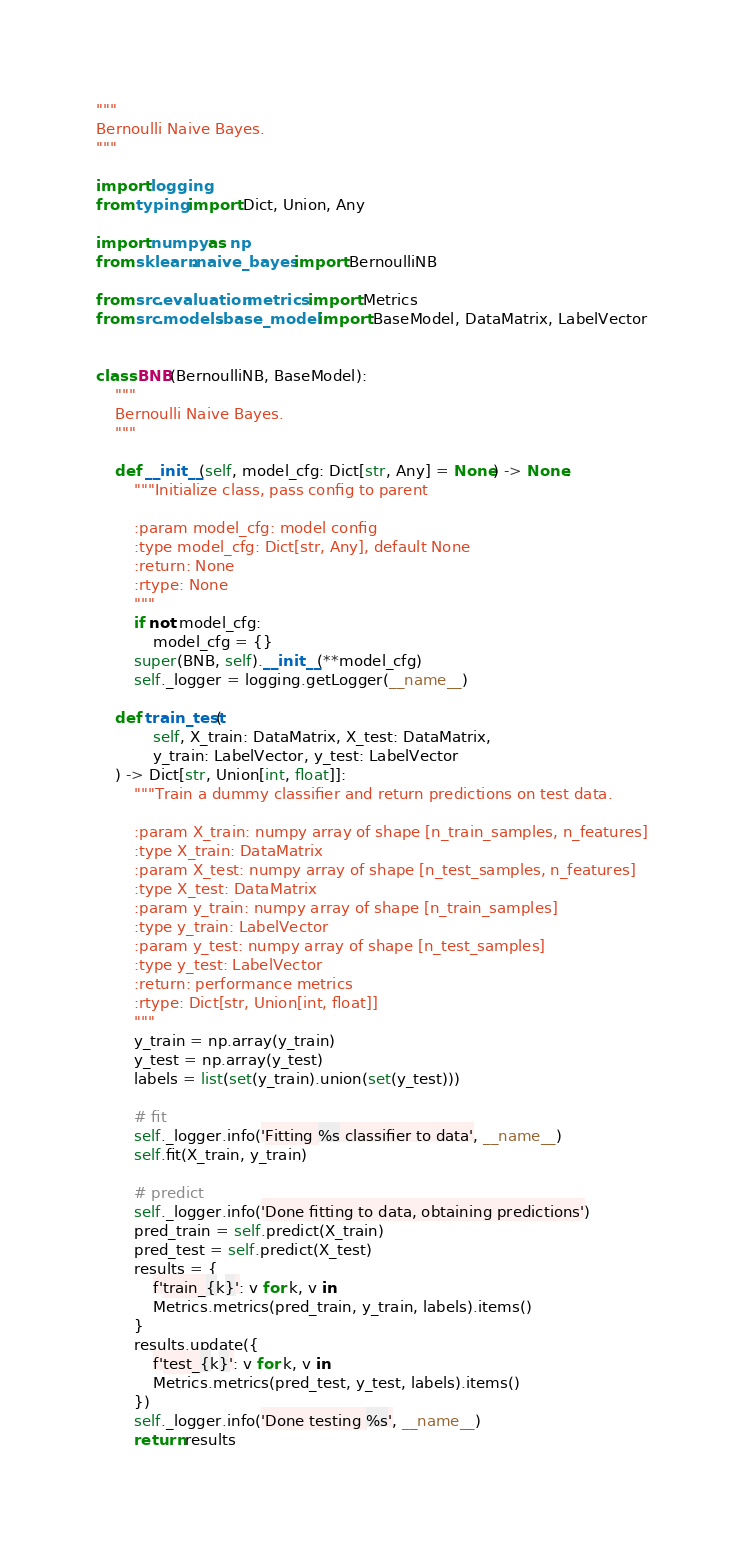Convert code to text. <code><loc_0><loc_0><loc_500><loc_500><_Python_>"""
Bernoulli Naive Bayes.
"""

import logging
from typing import Dict, Union, Any

import numpy as np
from sklearn.naive_bayes import BernoulliNB

from src.evaluation.metrics import Metrics
from src.models.base_model import BaseModel, DataMatrix, LabelVector


class BNB(BernoulliNB, BaseModel):
    """
    Bernoulli Naive Bayes.
    """

    def __init__(self, model_cfg: Dict[str, Any] = None) -> None:
        """Initialize class, pass config to parent

        :param model_cfg: model config
        :type model_cfg: Dict[str, Any], default None
        :return: None
        :rtype: None
        """
        if not model_cfg:
            model_cfg = {}
        super(BNB, self).__init__(**model_cfg)
        self._logger = logging.getLogger(__name__)

    def train_test(
            self, X_train: DataMatrix, X_test: DataMatrix,
            y_train: LabelVector, y_test: LabelVector
    ) -> Dict[str, Union[int, float]]:
        """Train a dummy classifier and return predictions on test data.

        :param X_train: numpy array of shape [n_train_samples, n_features]
        :type X_train: DataMatrix
        :param X_test: numpy array of shape [n_test_samples, n_features]
        :type X_test: DataMatrix
        :param y_train: numpy array of shape [n_train_samples]
        :type y_train: LabelVector
        :param y_test: numpy array of shape [n_test_samples]
        :type y_test: LabelVector
        :return: performance metrics
        :rtype: Dict[str, Union[int, float]]
        """
        y_train = np.array(y_train)
        y_test = np.array(y_test)
        labels = list(set(y_train).union(set(y_test)))

        # fit
        self._logger.info('Fitting %s classifier to data', __name__)
        self.fit(X_train, y_train)

        # predict
        self._logger.info('Done fitting to data, obtaining predictions')
        pred_train = self.predict(X_train)
        pred_test = self.predict(X_test)
        results = {
            f'train_{k}': v for k, v in
            Metrics.metrics(pred_train, y_train, labels).items()
        }
        results.update({
            f'test_{k}': v for k, v in
            Metrics.metrics(pred_test, y_test, labels).items()
        })
        self._logger.info('Done testing %s', __name__)
        return results
</code> 